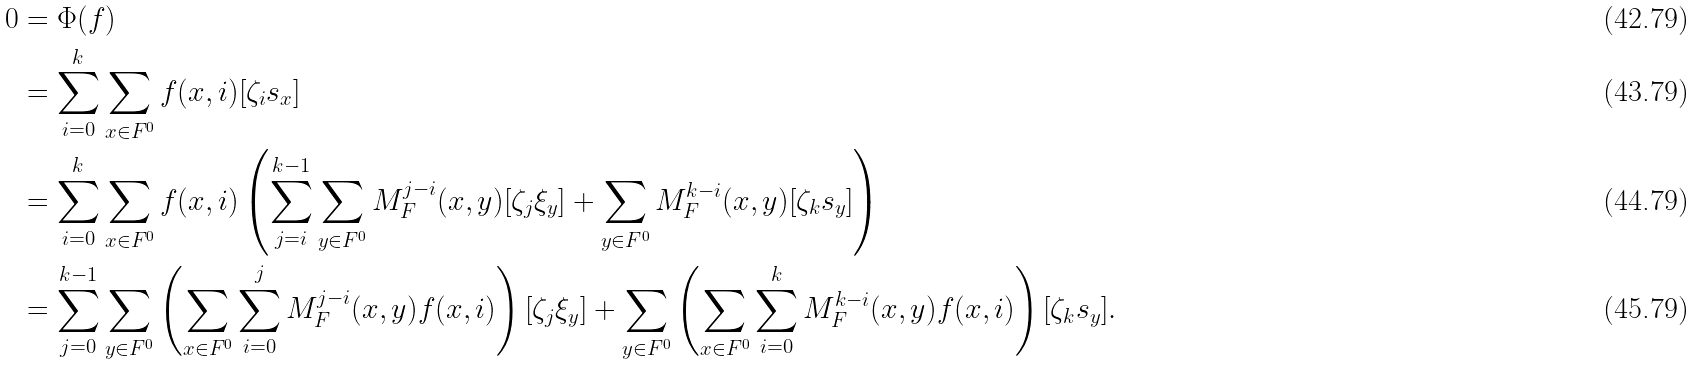<formula> <loc_0><loc_0><loc_500><loc_500>0 & = \Phi ( f ) \\ & = \sum _ { i = 0 } ^ { k } \sum _ { x \in F ^ { 0 } } f ( x , i ) [ \zeta _ { i } s _ { x } ] \\ & = \sum _ { i = 0 } ^ { k } \sum _ { x \in F ^ { 0 } } f ( x , i ) \left ( \sum _ { j = i } ^ { k - 1 } \sum _ { y \in F ^ { 0 } } M _ { F } ^ { j - i } ( x , y ) [ \zeta _ { j } \xi _ { y } ] + \sum _ { y \in F ^ { 0 } } M _ { F } ^ { k - i } ( x , y ) [ \zeta _ { k } s _ { y } ] \right ) \\ & = \sum _ { j = 0 } ^ { k - 1 } \sum _ { y \in F ^ { 0 } } \left ( \sum _ { x \in F ^ { 0 } } \sum _ { i = 0 } ^ { j } M _ { F } ^ { j - i } ( x , y ) f ( x , i ) \right ) [ \zeta _ { j } \xi _ { y } ] + \sum _ { y \in F ^ { 0 } } \left ( \sum _ { x \in F ^ { 0 } } \sum _ { i = 0 } ^ { k } M _ { F } ^ { k - i } ( x , y ) f ( x , i ) \right ) [ \zeta _ { k } s _ { y } ] .</formula> 